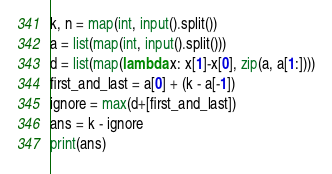Convert code to text. <code><loc_0><loc_0><loc_500><loc_500><_Python_>k, n = map(int, input().split())
a = list(map(int, input().split()))
d = list(map(lambda x: x[1]-x[0], zip(a, a[1:])))
first_and_last = a[0] + (k - a[-1])
ignore = max(d+[first_and_last])
ans = k - ignore
print(ans)</code> 